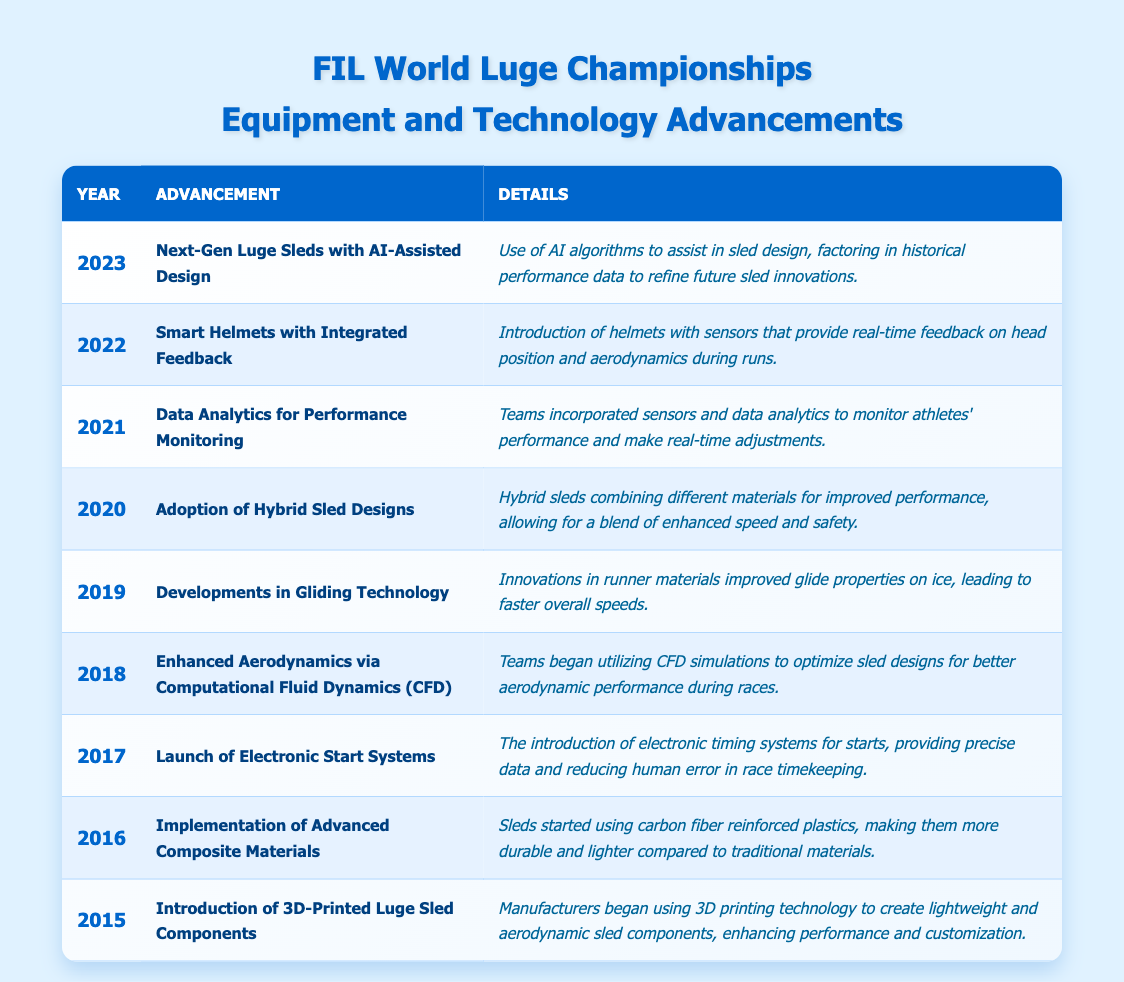What advancement was made in 2020? The table lists the advancements by year, and for 2020, it shows "Adoption of Hybrid Sled Designs" as the notable advancement.
Answer: Adoption of Hybrid Sled Designs Which material was introduced in sleds in 2016? By checking the 2016 row in the table, we can see that the advancement involves the "Implementation of Advanced Composite Materials."
Answer: Advanced Composite Materials In which year did they implement electronic start systems? The table provides the details for each year. In the row for 2017, it states that electronic start systems were launched.
Answer: 2017 How many advancements were made from 2015 to 2023? The table contains one advancement for each year from 2015 to 2023, which totals 9 advancements.
Answer: 9 What is the advancement related to data analytics? Looking at the year 2021 in the table, the advancement listed is "Data Analytics for Performance Monitoring."
Answer: Data Analytics for Performance Monitoring Which two years saw advancements related to feedback technology? Referring to the table, we can identify that 2021 (Data Analytics for Performance Monitoring) and 2022 (Smart Helmets with Integrated Feedback) focus on feedback technology.
Answer: 2021 and 2022 Did the introduction of 3D-printed components occur before or after 2016? The table indicates that the introduction of 3D-printed components was made in 2015, which is before 2016.
Answer: Before Which advancements focus on improving performance through material innovation? The advancements in 2016 (Advanced Composite Materials), 2019 (Gliding Technology), and 2020 (Hybrid Sled Designs) all focus on improving performance via material innovation.
Answer: 2016, 2019, and 2020 What has been the trend of technological advancements in luge from 2015 to 2023? By analyzing the table, it shows a clear trend towards incorporating technology such as data analytics, smart equipment, and AI in sled designs over the years, reflecting a focus on enhancing performance and safety.
Answer: Increasing incorporation of technology Which advancement was the first in the timeline? The first advancement listed in the table is for the year 2015, "Introduction of 3D-Printed Luge Sled Components."
Answer: Introduction of 3D-Printed Luge Sled Components What is the difference in the nature of advancements from 2015 to 2018 compared to 2019 to 2023? The first half focuses on material technologies (like 3D printing and composites), while the latter half introduces smart technology and analytics (like data monitoring, smart helmets, and AI).
Answer: Different focuses: Material vs. Smart technology Was AI used in sled design prior to 2023? The table shows "Next-Gen Luge Sleds with AI-Assisted Design" as the advancement in 2023, indicating that AI was not utilized in sled design before this year.
Answer: No 